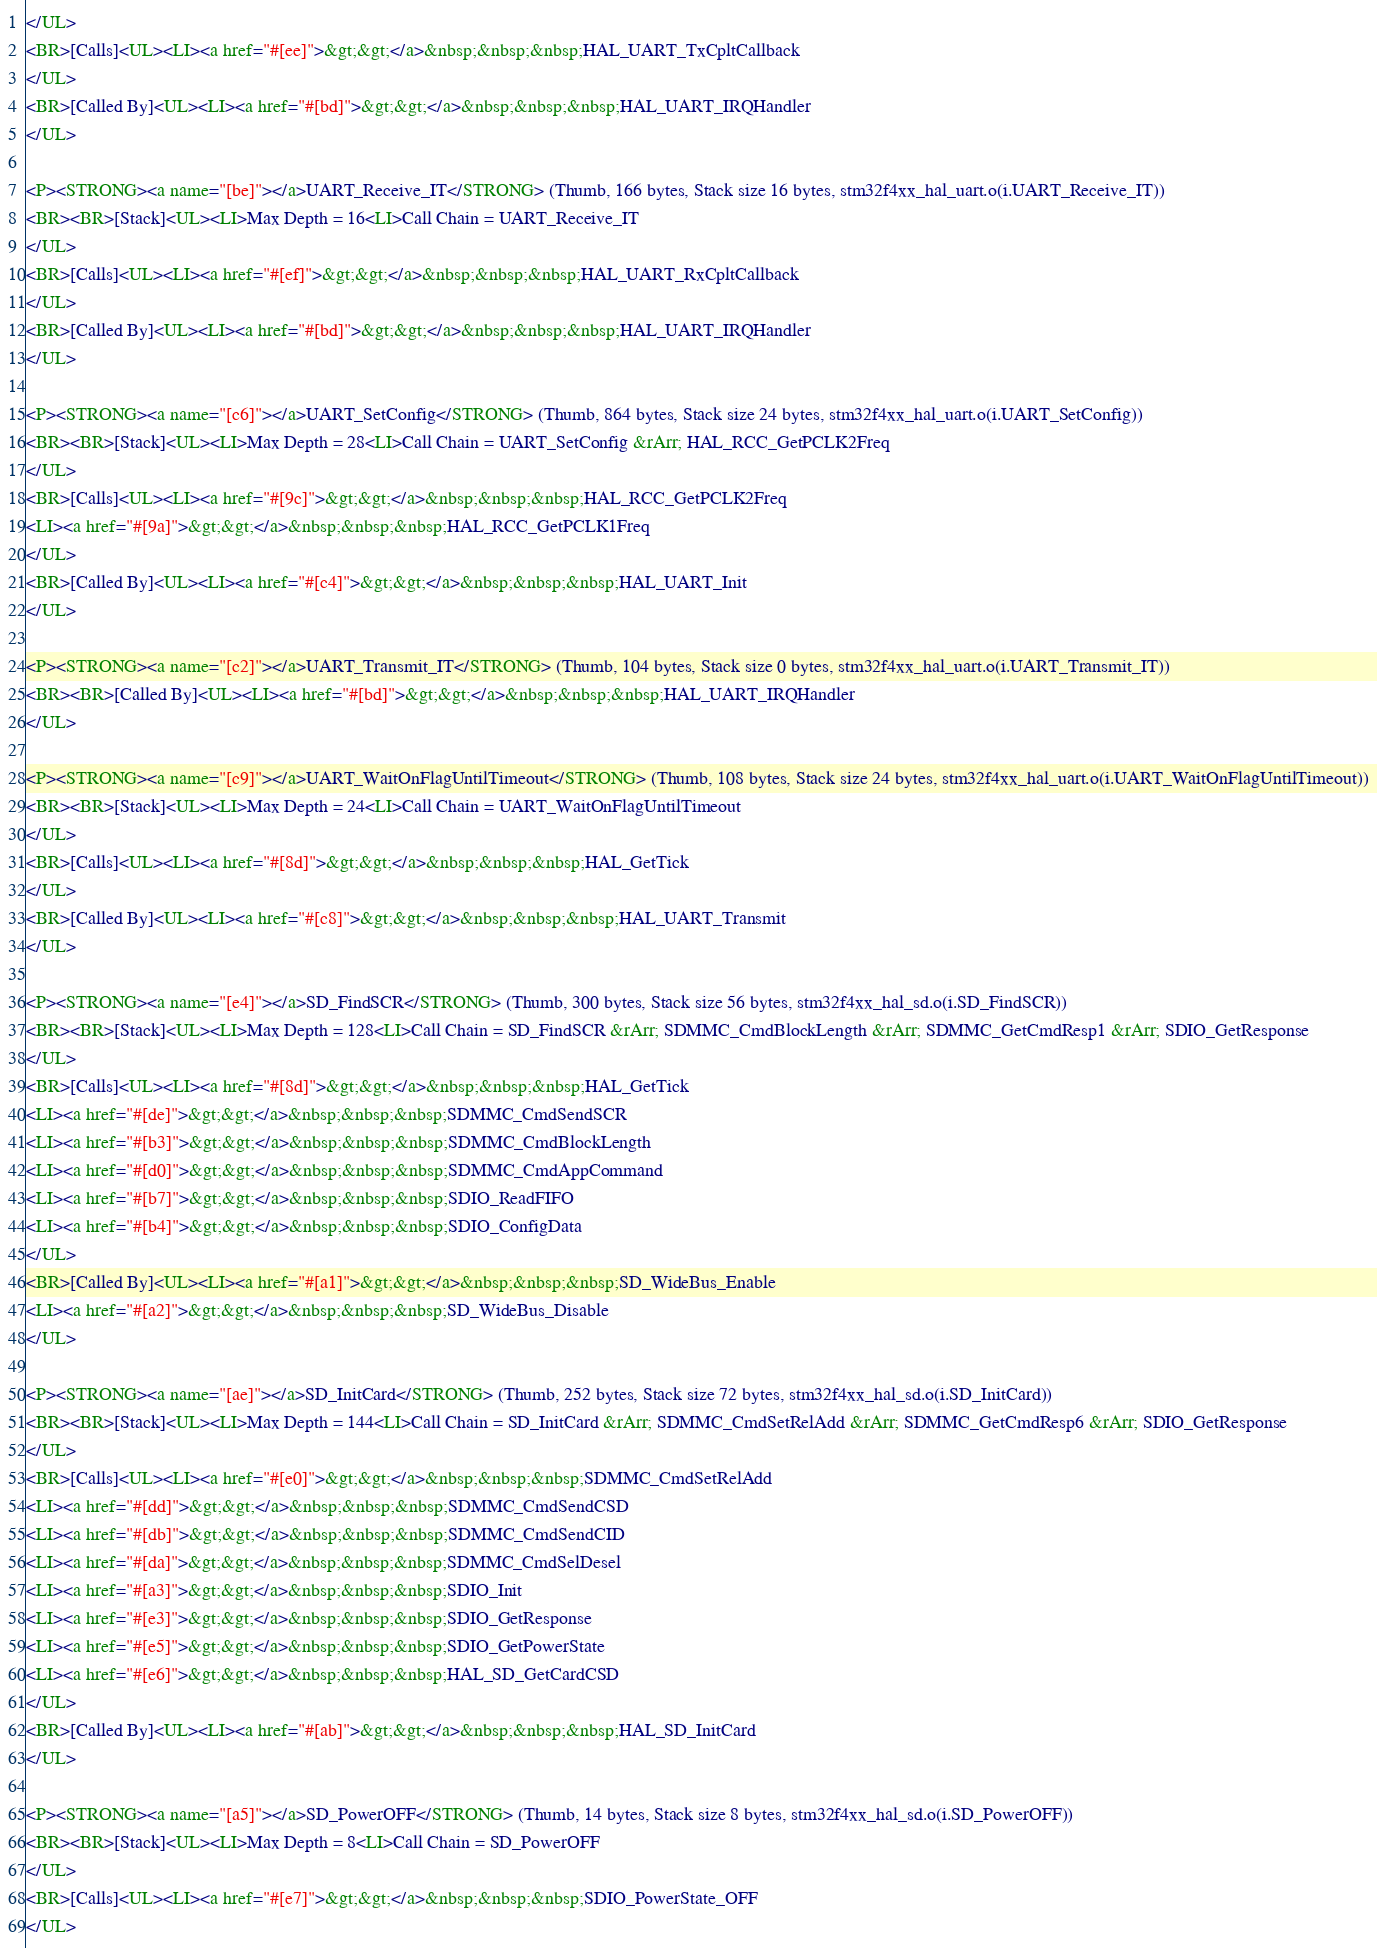<code> <loc_0><loc_0><loc_500><loc_500><_HTML_></UL>
<BR>[Calls]<UL><LI><a href="#[ee]">&gt;&gt;</a>&nbsp;&nbsp;&nbsp;HAL_UART_TxCpltCallback
</UL>
<BR>[Called By]<UL><LI><a href="#[bd]">&gt;&gt;</a>&nbsp;&nbsp;&nbsp;HAL_UART_IRQHandler
</UL>

<P><STRONG><a name="[be]"></a>UART_Receive_IT</STRONG> (Thumb, 166 bytes, Stack size 16 bytes, stm32f4xx_hal_uart.o(i.UART_Receive_IT))
<BR><BR>[Stack]<UL><LI>Max Depth = 16<LI>Call Chain = UART_Receive_IT
</UL>
<BR>[Calls]<UL><LI><a href="#[ef]">&gt;&gt;</a>&nbsp;&nbsp;&nbsp;HAL_UART_RxCpltCallback
</UL>
<BR>[Called By]<UL><LI><a href="#[bd]">&gt;&gt;</a>&nbsp;&nbsp;&nbsp;HAL_UART_IRQHandler
</UL>

<P><STRONG><a name="[c6]"></a>UART_SetConfig</STRONG> (Thumb, 864 bytes, Stack size 24 bytes, stm32f4xx_hal_uart.o(i.UART_SetConfig))
<BR><BR>[Stack]<UL><LI>Max Depth = 28<LI>Call Chain = UART_SetConfig &rArr; HAL_RCC_GetPCLK2Freq
</UL>
<BR>[Calls]<UL><LI><a href="#[9c]">&gt;&gt;</a>&nbsp;&nbsp;&nbsp;HAL_RCC_GetPCLK2Freq
<LI><a href="#[9a]">&gt;&gt;</a>&nbsp;&nbsp;&nbsp;HAL_RCC_GetPCLK1Freq
</UL>
<BR>[Called By]<UL><LI><a href="#[c4]">&gt;&gt;</a>&nbsp;&nbsp;&nbsp;HAL_UART_Init
</UL>

<P><STRONG><a name="[c2]"></a>UART_Transmit_IT</STRONG> (Thumb, 104 bytes, Stack size 0 bytes, stm32f4xx_hal_uart.o(i.UART_Transmit_IT))
<BR><BR>[Called By]<UL><LI><a href="#[bd]">&gt;&gt;</a>&nbsp;&nbsp;&nbsp;HAL_UART_IRQHandler
</UL>

<P><STRONG><a name="[c9]"></a>UART_WaitOnFlagUntilTimeout</STRONG> (Thumb, 108 bytes, Stack size 24 bytes, stm32f4xx_hal_uart.o(i.UART_WaitOnFlagUntilTimeout))
<BR><BR>[Stack]<UL><LI>Max Depth = 24<LI>Call Chain = UART_WaitOnFlagUntilTimeout
</UL>
<BR>[Calls]<UL><LI><a href="#[8d]">&gt;&gt;</a>&nbsp;&nbsp;&nbsp;HAL_GetTick
</UL>
<BR>[Called By]<UL><LI><a href="#[c8]">&gt;&gt;</a>&nbsp;&nbsp;&nbsp;HAL_UART_Transmit
</UL>

<P><STRONG><a name="[e4]"></a>SD_FindSCR</STRONG> (Thumb, 300 bytes, Stack size 56 bytes, stm32f4xx_hal_sd.o(i.SD_FindSCR))
<BR><BR>[Stack]<UL><LI>Max Depth = 128<LI>Call Chain = SD_FindSCR &rArr; SDMMC_CmdBlockLength &rArr; SDMMC_GetCmdResp1 &rArr; SDIO_GetResponse
</UL>
<BR>[Calls]<UL><LI><a href="#[8d]">&gt;&gt;</a>&nbsp;&nbsp;&nbsp;HAL_GetTick
<LI><a href="#[de]">&gt;&gt;</a>&nbsp;&nbsp;&nbsp;SDMMC_CmdSendSCR
<LI><a href="#[b3]">&gt;&gt;</a>&nbsp;&nbsp;&nbsp;SDMMC_CmdBlockLength
<LI><a href="#[d0]">&gt;&gt;</a>&nbsp;&nbsp;&nbsp;SDMMC_CmdAppCommand
<LI><a href="#[b7]">&gt;&gt;</a>&nbsp;&nbsp;&nbsp;SDIO_ReadFIFO
<LI><a href="#[b4]">&gt;&gt;</a>&nbsp;&nbsp;&nbsp;SDIO_ConfigData
</UL>
<BR>[Called By]<UL><LI><a href="#[a1]">&gt;&gt;</a>&nbsp;&nbsp;&nbsp;SD_WideBus_Enable
<LI><a href="#[a2]">&gt;&gt;</a>&nbsp;&nbsp;&nbsp;SD_WideBus_Disable
</UL>

<P><STRONG><a name="[ae]"></a>SD_InitCard</STRONG> (Thumb, 252 bytes, Stack size 72 bytes, stm32f4xx_hal_sd.o(i.SD_InitCard))
<BR><BR>[Stack]<UL><LI>Max Depth = 144<LI>Call Chain = SD_InitCard &rArr; SDMMC_CmdSetRelAdd &rArr; SDMMC_GetCmdResp6 &rArr; SDIO_GetResponse
</UL>
<BR>[Calls]<UL><LI><a href="#[e0]">&gt;&gt;</a>&nbsp;&nbsp;&nbsp;SDMMC_CmdSetRelAdd
<LI><a href="#[dd]">&gt;&gt;</a>&nbsp;&nbsp;&nbsp;SDMMC_CmdSendCSD
<LI><a href="#[db]">&gt;&gt;</a>&nbsp;&nbsp;&nbsp;SDMMC_CmdSendCID
<LI><a href="#[da]">&gt;&gt;</a>&nbsp;&nbsp;&nbsp;SDMMC_CmdSelDesel
<LI><a href="#[a3]">&gt;&gt;</a>&nbsp;&nbsp;&nbsp;SDIO_Init
<LI><a href="#[e3]">&gt;&gt;</a>&nbsp;&nbsp;&nbsp;SDIO_GetResponse
<LI><a href="#[e5]">&gt;&gt;</a>&nbsp;&nbsp;&nbsp;SDIO_GetPowerState
<LI><a href="#[e6]">&gt;&gt;</a>&nbsp;&nbsp;&nbsp;HAL_SD_GetCardCSD
</UL>
<BR>[Called By]<UL><LI><a href="#[ab]">&gt;&gt;</a>&nbsp;&nbsp;&nbsp;HAL_SD_InitCard
</UL>

<P><STRONG><a name="[a5]"></a>SD_PowerOFF</STRONG> (Thumb, 14 bytes, Stack size 8 bytes, stm32f4xx_hal_sd.o(i.SD_PowerOFF))
<BR><BR>[Stack]<UL><LI>Max Depth = 8<LI>Call Chain = SD_PowerOFF
</UL>
<BR>[Calls]<UL><LI><a href="#[e7]">&gt;&gt;</a>&nbsp;&nbsp;&nbsp;SDIO_PowerState_OFF
</UL></code> 